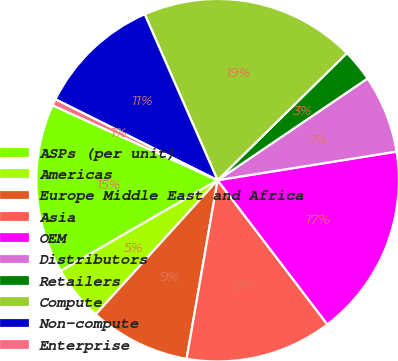Convert chart. <chart><loc_0><loc_0><loc_500><loc_500><pie_chart><fcel>ASPs (per unit)<fcel>Americas<fcel>Europe Middle East and Africa<fcel>Asia<fcel>OEM<fcel>Distributors<fcel>Retailers<fcel>Compute<fcel>Non-compute<fcel>Enterprise<nl><fcel>15.13%<fcel>4.92%<fcel>9.0%<fcel>13.09%<fcel>17.17%<fcel>6.96%<fcel>2.88%<fcel>19.22%<fcel>11.05%<fcel>0.58%<nl></chart> 